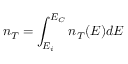Convert formula to latex. <formula><loc_0><loc_0><loc_500><loc_500>n _ { T } = \int _ { E _ { i } } ^ { E _ { C } } n _ { T } ( E ) d E</formula> 